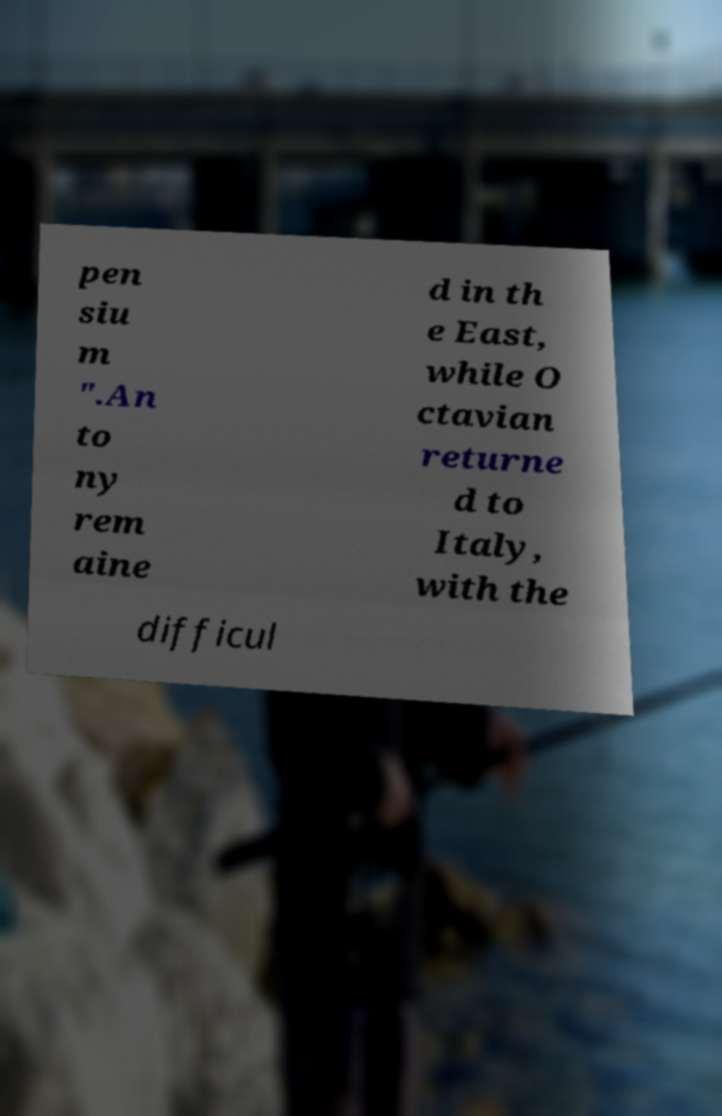Could you extract and type out the text from this image? pen siu m ".An to ny rem aine d in th e East, while O ctavian returne d to Italy, with the difficul 